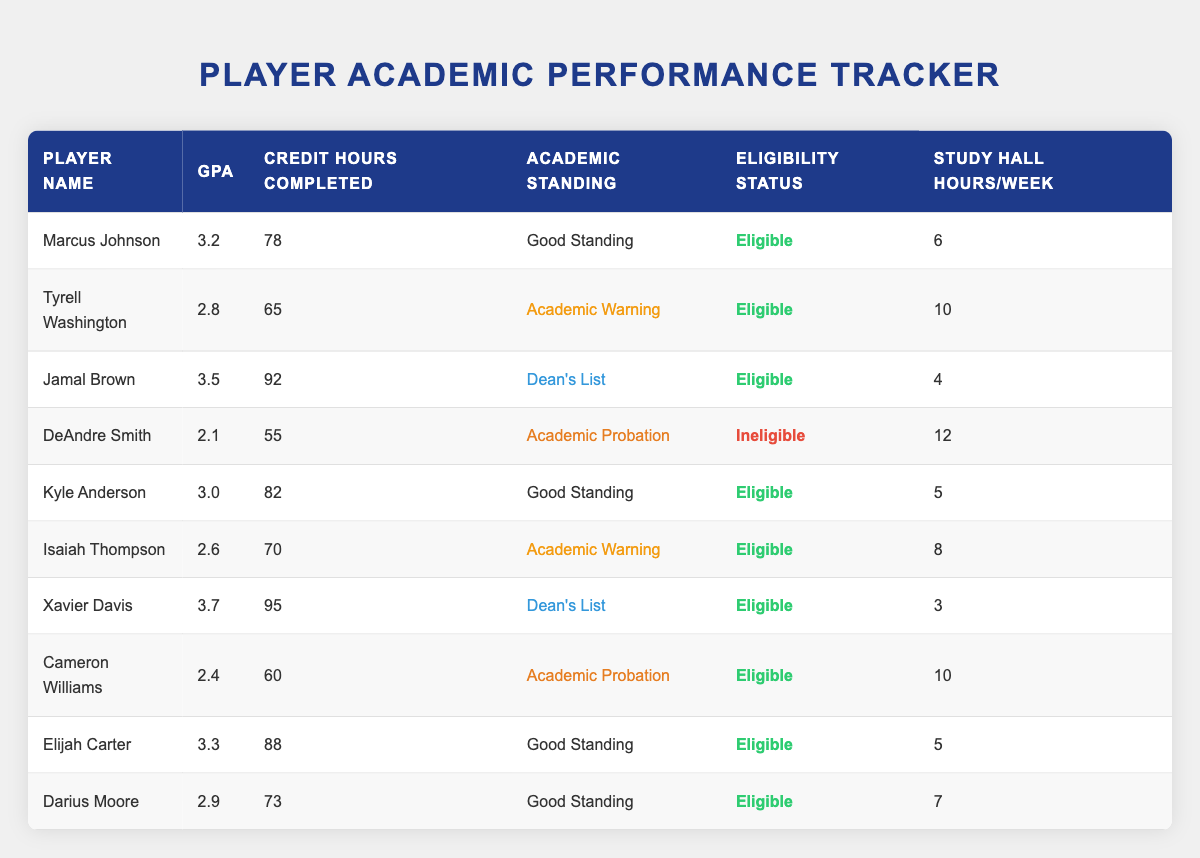What is the GPA of Jamal Brown? To find the GPA of Jamal Brown, we look for his row in the table. He is listed with a GPA of 3.5.
Answer: 3.5 How many players are in Academic Probation? In the table, we can identify which players are in Academic Probation by looking under the Academic Standing column. Two players, DeAndre Smith and Cameron Williams, are in Academic Probation.
Answer: 2 What is the average GPA of players listed as Eligible? To calculate the average GPA of Eligible players, we first gather their GPAs: 3.2, 2.8, 3.5, 3.0, 2.6, 3.7, 2.4, 3.3, and 2.9. Adding these together gives us 24.0. There are 9 Eligible players. Then, we divide the total GPA by the number of players: 24.0/9 = 2.67.
Answer: 2.67 Are there any players with a GPA below 2.5? By scanning through the GPA column, we see that only DeAndre Smith (2.1) and Cameron Williams (2.4) have GPAs below 2.5. Therefore, the answer is yes.
Answer: Yes What is the total number of credit hours completed by players in Good Standing? We look for the players listed as in Good Standing: Marcus Johnson (78), Kyle Anderson (82), Elijah Carter (88), and Darius Moore (73). The total credit hours completed is: 78 + 82 + 88 + 73 = 321.
Answer: 321 Which player has the highest GPA and what is it? By reviewing the table, we can see that Xavier Davis has the highest GPA at 3.7.
Answer: Xavier Davis, 3.7 What percentage of players studied more than 8 hours a week? Count players with over 8 study hall hours: Tyrell Washington (10), DeAndre Smith (12), and Cameron Williams (10). There are 3 players studying more than 8 hours (out of 10 total players), which gives us 3 out of 10. To find the percentage: (3/10) * 100 = 30%.
Answer: 30% Which player has the lowest Credit Hours Completed and what is it? By looking through the Credit Hours Completed column, we see that DeAndre Smith has the lowest with 55 credit hours.
Answer: DeAndre Smith, 55 How many players are on the Dean's List? In the Academic Standing column, we identify players who made the Dean's List: Jamal Brown and Xavier Davis. Therefore, there are 2 players on the Dean's List.
Answer: 2 